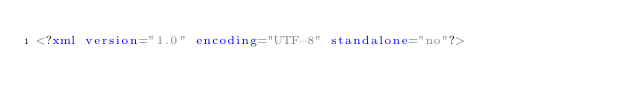Convert code to text. <code><loc_0><loc_0><loc_500><loc_500><_XML_><?xml version="1.0" encoding="UTF-8" standalone="no"?></code> 